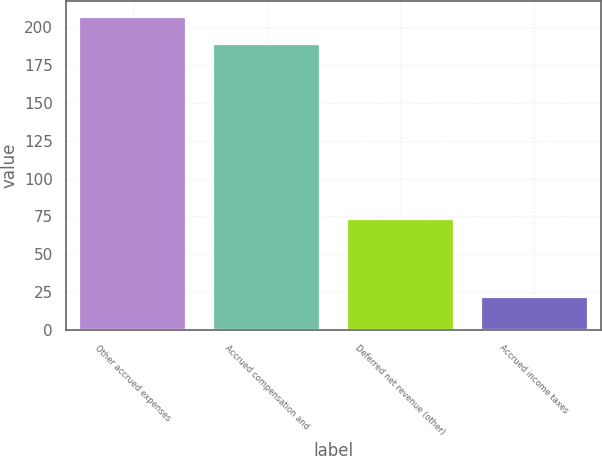Convert chart to OTSL. <chart><loc_0><loc_0><loc_500><loc_500><bar_chart><fcel>Other accrued expenses<fcel>Accrued compensation and<fcel>Deferred net revenue (other)<fcel>Accrued income taxes<nl><fcel>206.7<fcel>189<fcel>73<fcel>22<nl></chart> 